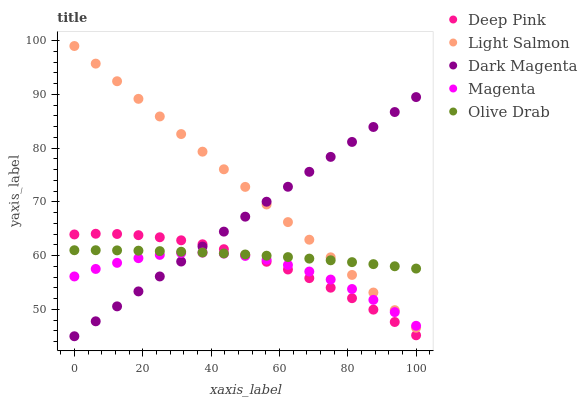Does Magenta have the minimum area under the curve?
Answer yes or no. Yes. Does Light Salmon have the maximum area under the curve?
Answer yes or no. Yes. Does Deep Pink have the minimum area under the curve?
Answer yes or no. No. Does Deep Pink have the maximum area under the curve?
Answer yes or no. No. Is Dark Magenta the smoothest?
Answer yes or no. Yes. Is Magenta the roughest?
Answer yes or no. Yes. Is Light Salmon the smoothest?
Answer yes or no. No. Is Light Salmon the roughest?
Answer yes or no. No. Does Dark Magenta have the lowest value?
Answer yes or no. Yes. Does Light Salmon have the lowest value?
Answer yes or no. No. Does Light Salmon have the highest value?
Answer yes or no. Yes. Does Deep Pink have the highest value?
Answer yes or no. No. Is Magenta less than Olive Drab?
Answer yes or no. Yes. Is Olive Drab greater than Magenta?
Answer yes or no. Yes. Does Light Salmon intersect Olive Drab?
Answer yes or no. Yes. Is Light Salmon less than Olive Drab?
Answer yes or no. No. Is Light Salmon greater than Olive Drab?
Answer yes or no. No. Does Magenta intersect Olive Drab?
Answer yes or no. No. 